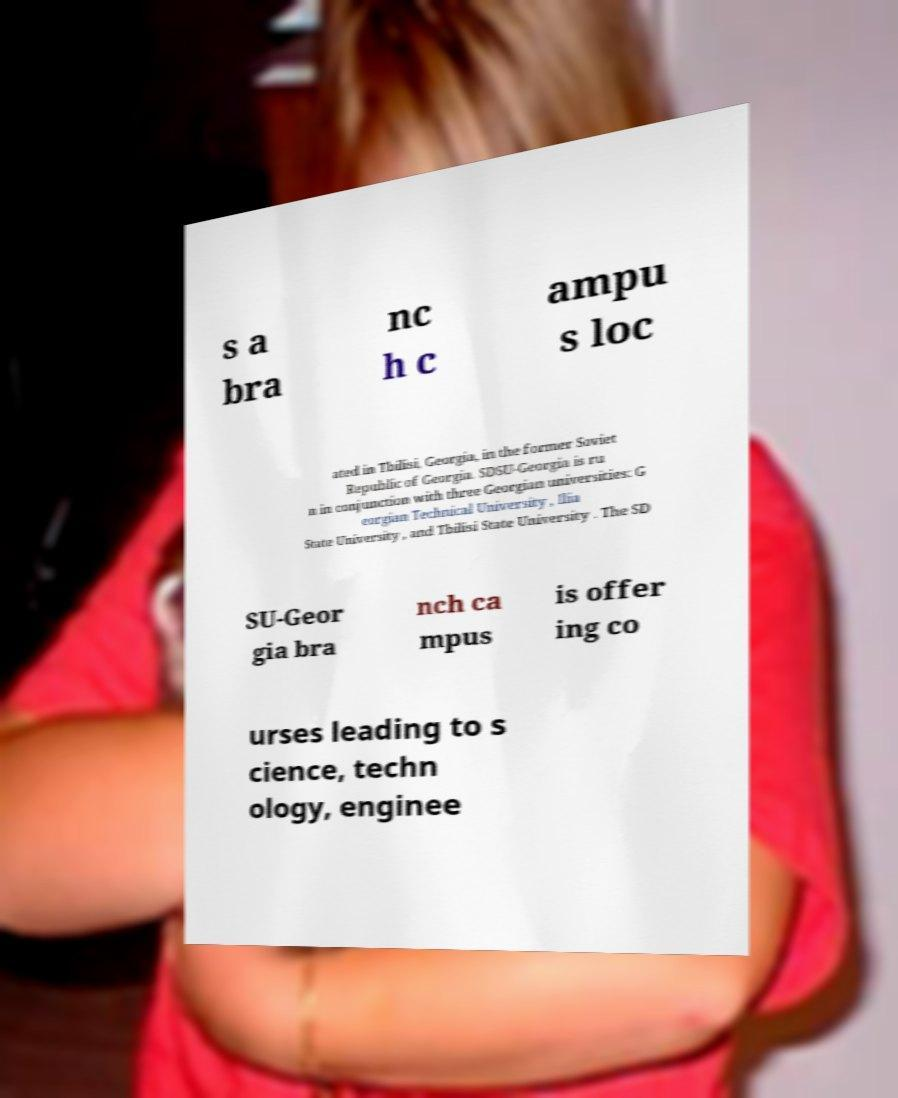What messages or text are displayed in this image? I need them in a readable, typed format. s a bra nc h c ampu s loc ated in Tbilisi, Georgia, in the former Soviet Republic of Georgia. SDSU-Georgia is ru n in conjunction with three Georgian universities: G eorgian Technical University , Ilia State University , and Tbilisi State University . The SD SU-Geor gia bra nch ca mpus is offer ing co urses leading to s cience, techn ology, enginee 